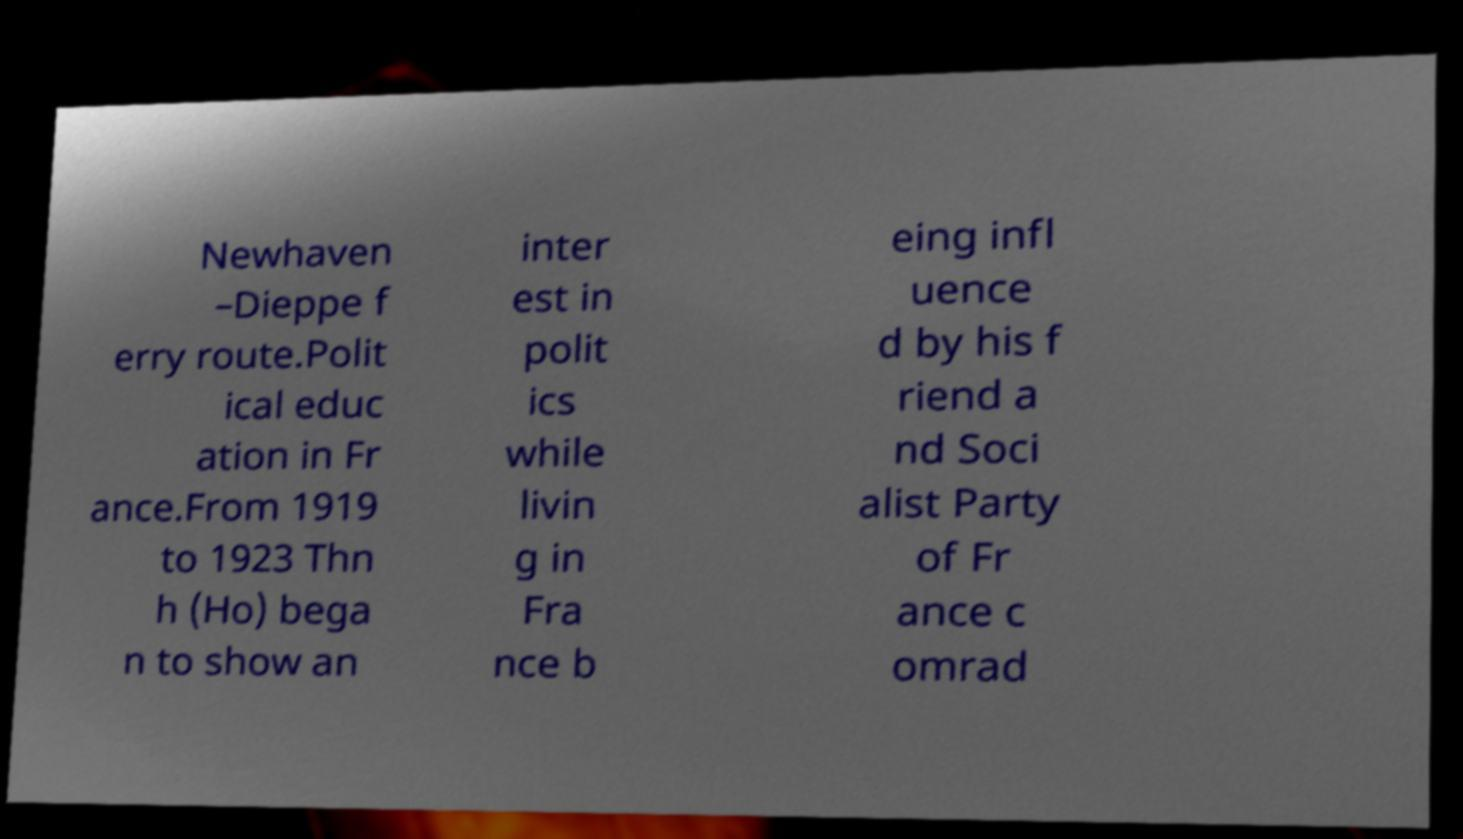Can you accurately transcribe the text from the provided image for me? Newhaven –Dieppe f erry route.Polit ical educ ation in Fr ance.From 1919 to 1923 Thn h (Ho) bega n to show an inter est in polit ics while livin g in Fra nce b eing infl uence d by his f riend a nd Soci alist Party of Fr ance c omrad 